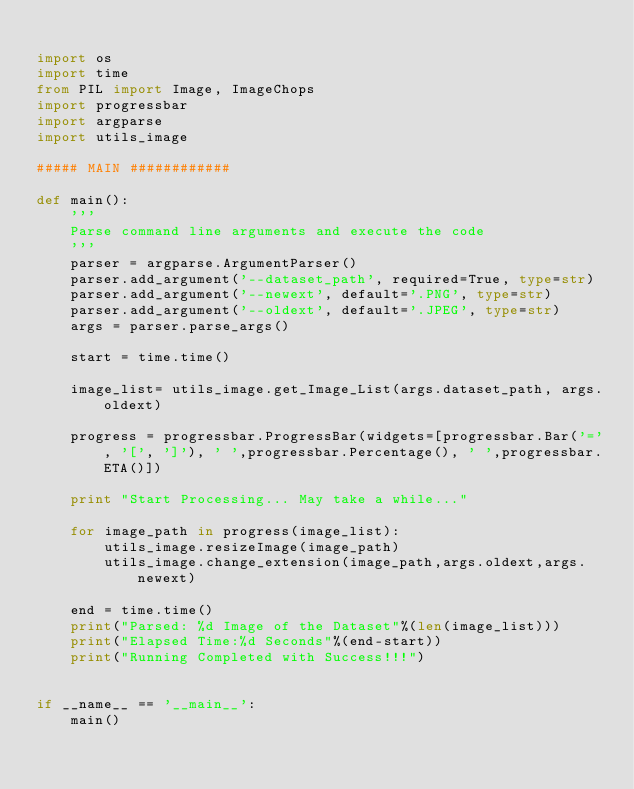Convert code to text. <code><loc_0><loc_0><loc_500><loc_500><_Python_>
import os
import time
from PIL import Image, ImageChops
import progressbar
import argparse
import utils_image

##### MAIN ############

def main():
    '''
    Parse command line arguments and execute the code
    '''
    parser = argparse.ArgumentParser()
    parser.add_argument('--dataset_path', required=True, type=str)
    parser.add_argument('--newext', default='.PNG', type=str)
    parser.add_argument('--oldext', default='.JPEG', type=str)
    args = parser.parse_args()

    start = time.time()

    image_list= utils_image.get_Image_List(args.dataset_path, args.oldext)

    progress = progressbar.ProgressBar(widgets=[progressbar.Bar('=', '[', ']'), ' ',progressbar.Percentage(), ' ',progressbar.ETA()])

    print "Start Processing... May take a while..."

    for image_path in progress(image_list):
        utils_image.resizeImage(image_path)
        utils_image.change_extension(image_path,args.oldext,args.newext)
 
    end = time.time()
    print("Parsed: %d Image of the Dataset"%(len(image_list)))
    print("Elapsed Time:%d Seconds"%(end-start))
    print("Running Completed with Success!!!")


if __name__ == '__main__':
    main()</code> 